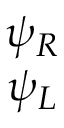<formula> <loc_0><loc_0><loc_500><loc_500>\begin{array} { c } { { \psi _ { R } } } \\ { { \psi _ { L } } } \end{array}</formula> 